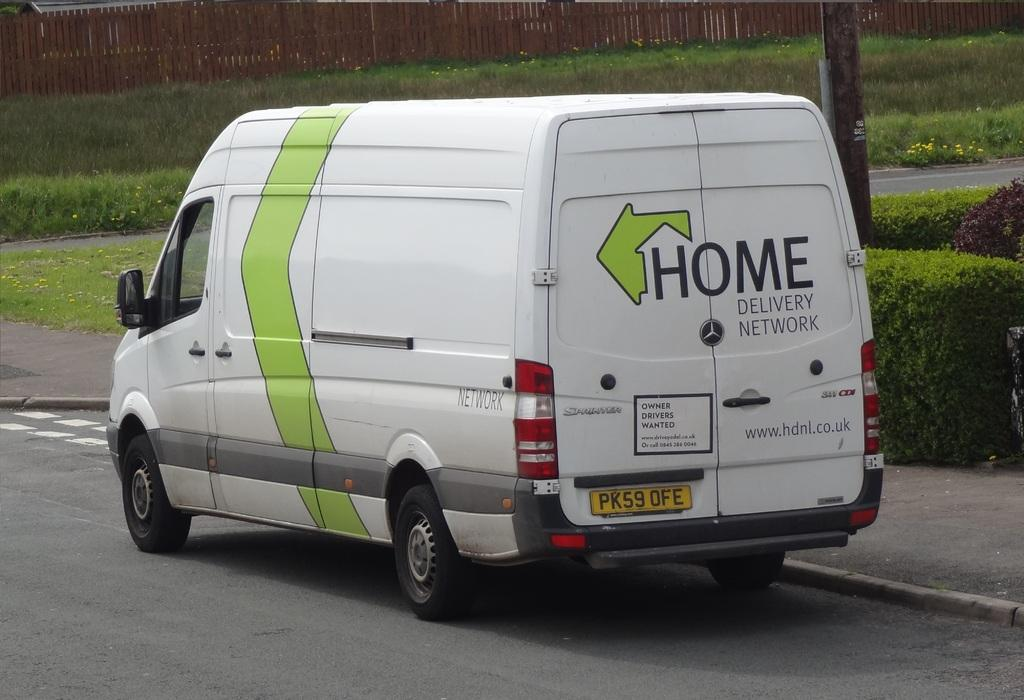<image>
Create a compact narrative representing the image presented. The green and white van says Home Delivery Network. 